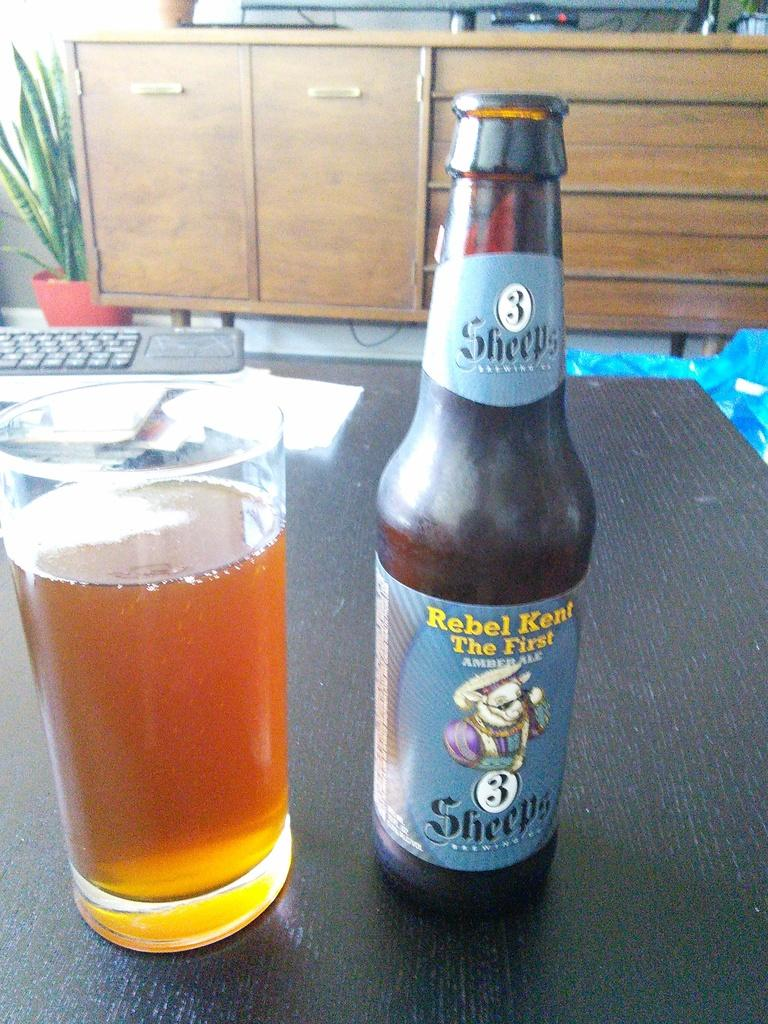<image>
Offer a succinct explanation of the picture presented. A bottle of Rebel Kent The First Amber Ale on a table next to a glass of Rebel Kent. 